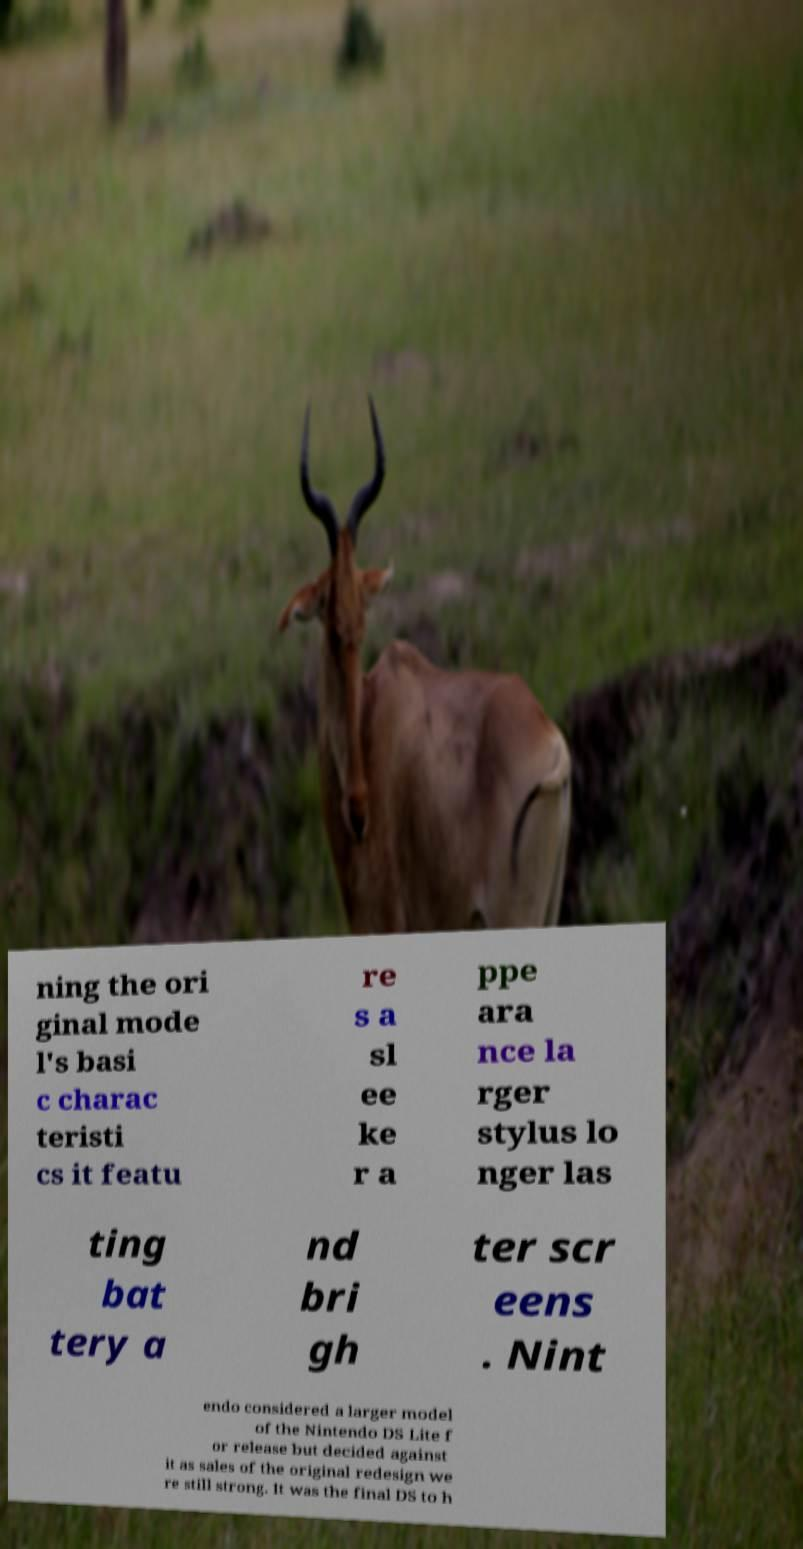What messages or text are displayed in this image? I need them in a readable, typed format. ning the ori ginal mode l's basi c charac teristi cs it featu re s a sl ee ke r a ppe ara nce la rger stylus lo nger las ting bat tery a nd bri gh ter scr eens . Nint endo considered a larger model of the Nintendo DS Lite f or release but decided against it as sales of the original redesign we re still strong. It was the final DS to h 